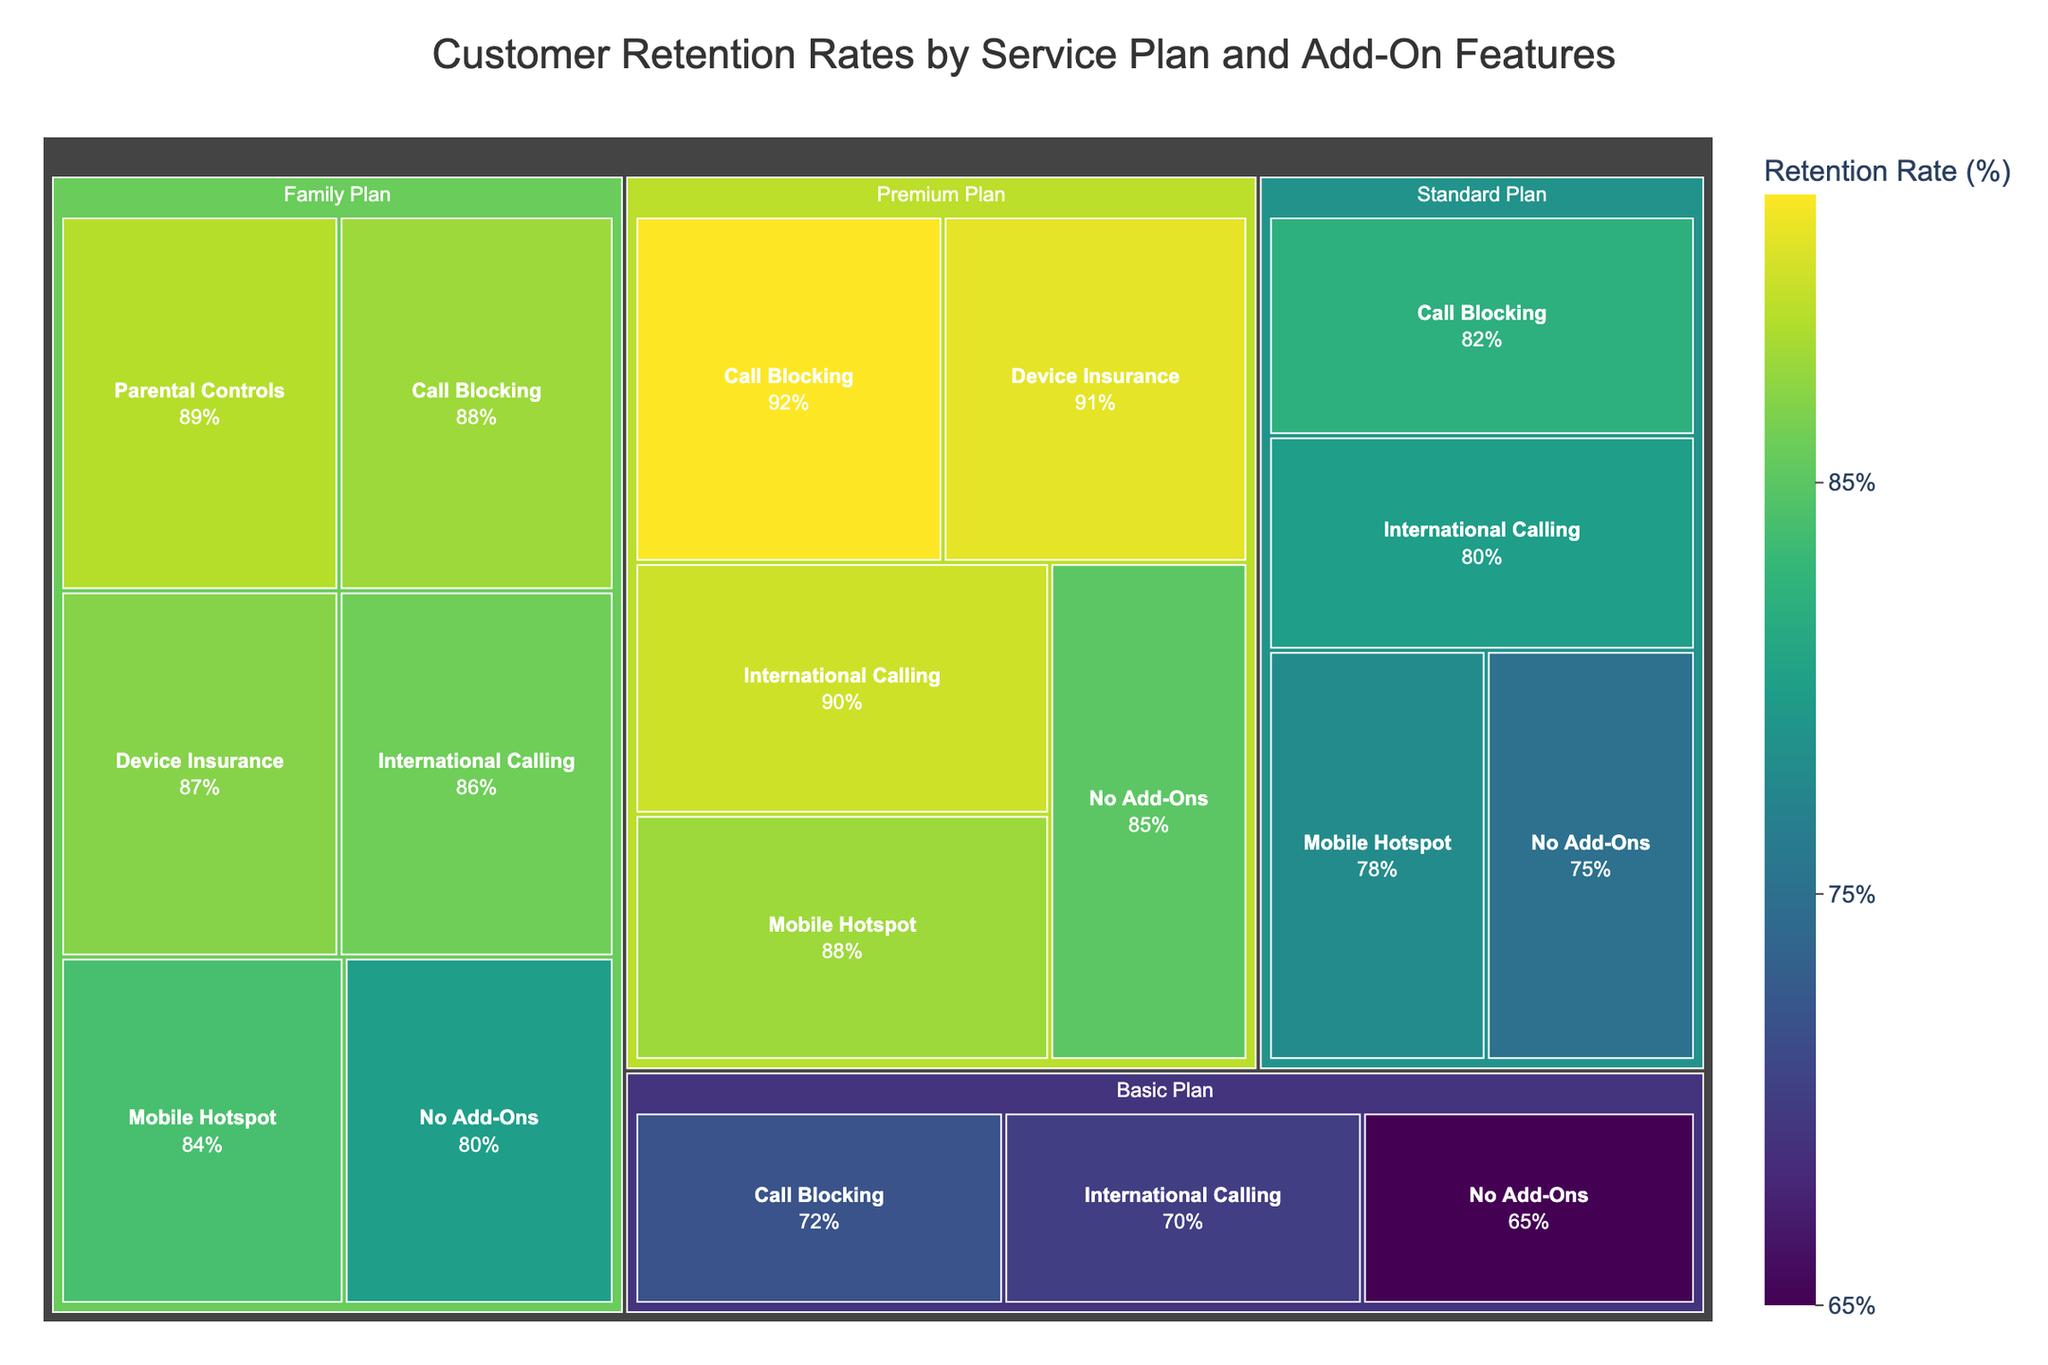How many service plans are included in the treemap? The figure has different sections representing service plans, each containing data regarding their specific add-on features. By counting these sections, we determine there are Basic Plan, Standard Plan, Premium Plan, and Family Plan.
Answer: 4 Which add-on feature has the highest retention rate for the Premium Plan? Within the Premium Plan portion of the treemap, the retention rates for all add-on features are shown. By identifying the highest value under this category, it is Call Blocking with 92%.
Answer: Call Blocking What is the average retention rate for the Standard Plan's add-on features? To calculate the average, sum the retention rates of all Standard Plan's add-ons and divide by the number of these features. The rates are 82%, 80%, and 78%. Thus, the average is (82 + 80 + 78) / 3 = 80%.
Answer: 80% Which service plan has the lowest retention rate with no add-ons? By looking at the treemap, compare sections for each plan with 'No Add-Ons'. The values are Basic Plan (65%), Standard Plan (75%), Premium Plan (85%), and Family Plan (80%). The lowest is the Basic Plan at 65%.
Answer: Basic Plan How does the retention rate of International Calling in the Family Plan compare with that of the Basic Plan? Examine the retention rates for International Calling in both plans. For the Family Plan, it is 86%, and for the Basic Plan, it is 70%. The Family Plan has a higher rate.
Answer: Family Plan has a higher rate What is the median retention rate for all add-on features in the Basic Plan? List the rates (72%, 70%, 65%) and identify the middle value. Sorting the values as (65, 70, 72), the median is the middle one.
Answer: 70% Which service plan consistently has higher retention rates across all its add-ons? Compare each plan's add-on retention rates. The Premium Plan has retention rates of 92%, 90%, 88%, and 91%, which are consistently higher than the corresponding rates in other plans.
Answer: Premium Plan What is the difference in retention rate between Call Blocking and Mobile Hotspot in the Family Plan? Check the rates within the Family Plan section for Call Blocking (88%) and Mobile Hotspot (84%). Subtract the smaller from the larger, 88% - 84% = 4%.
Answer: 4% Which service plan and add-on combination has the smallest retention rate? Compare all sections for their smallest values. The Basic Plan with No Add-Ons has the smallest rate at 65%.
Answer: Basic Plan with No Add-Ons Which feature impacts retention rate the most among all the plans? Look for the highest retention rates across all sections. Call Blocking in the Premium Plan has the highest rate at 92%, suggesting it has the most significant impact on retention.
Answer: Call Blocking in Premium Plan 